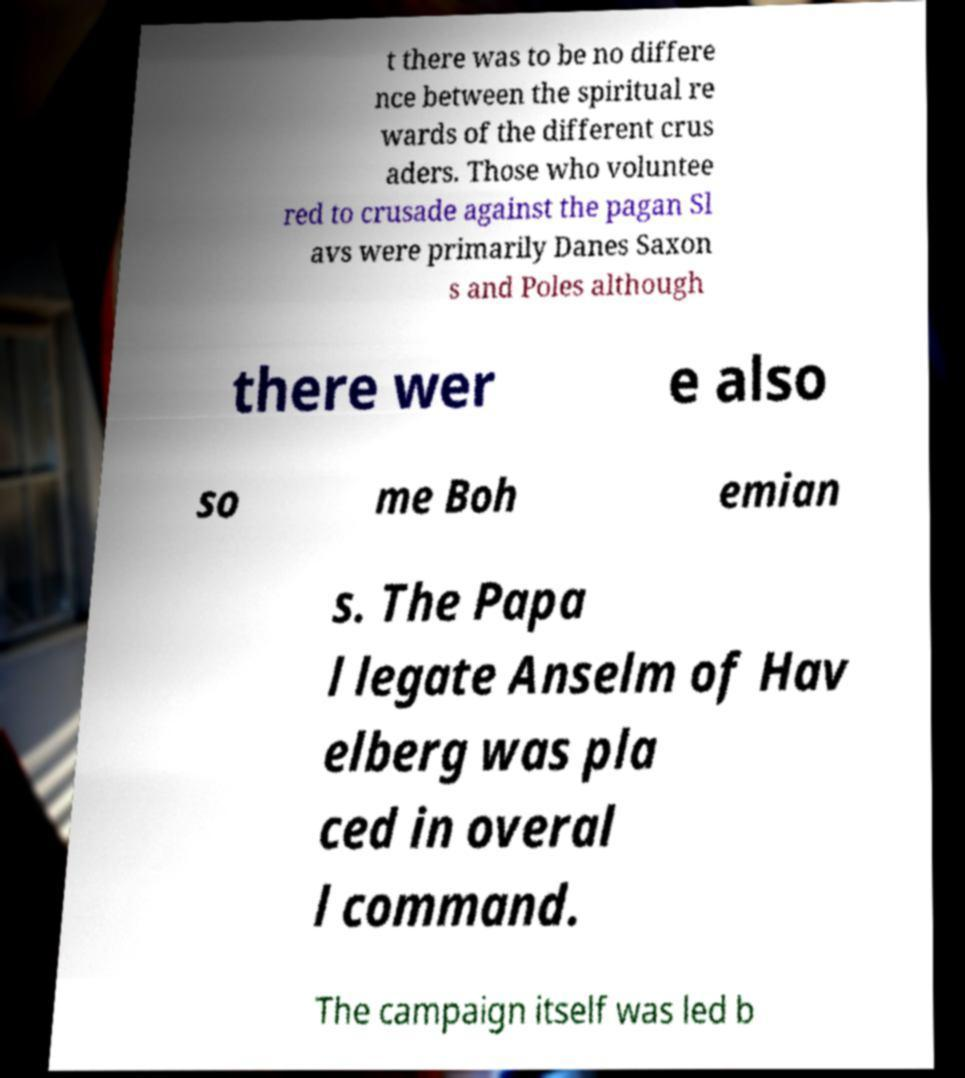Can you accurately transcribe the text from the provided image for me? t there was to be no differe nce between the spiritual re wards of the different crus aders. Those who voluntee red to crusade against the pagan Sl avs were primarily Danes Saxon s and Poles although there wer e also so me Boh emian s. The Papa l legate Anselm of Hav elberg was pla ced in overal l command. The campaign itself was led b 